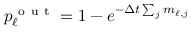<formula> <loc_0><loc_0><loc_500><loc_500>p _ { \ell } ^ { o u t } = 1 - e ^ { - \Delta t \sum _ { j } m _ { \ell , j } }</formula> 